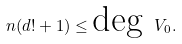<formula> <loc_0><loc_0><loc_500><loc_500>n ( d ! + 1 ) \leq \text {deg } V _ { 0 } .</formula> 